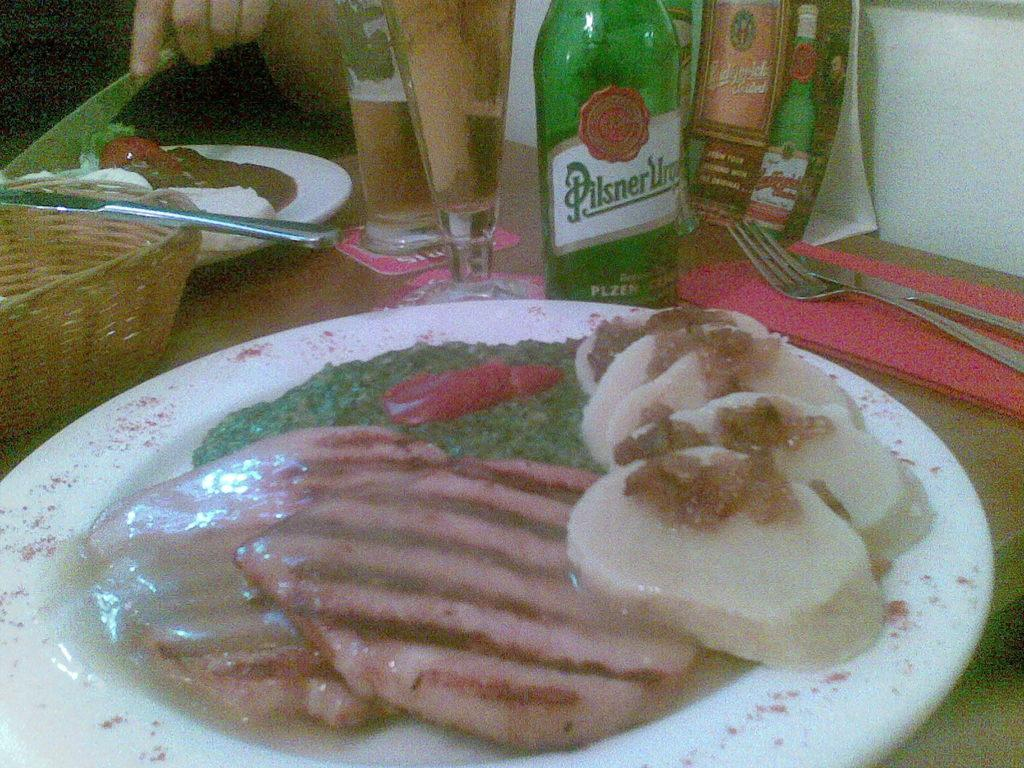What is the person in the image holding? The person in the image is holding a knife. What can be seen on the table in the image? There are serving plates with food, cutlery, glass tumblers, a woven basket, and beverage bottles on the table. What might be used for cutting or slicing in the image? The knife held by the person might be used for cutting or slicing. What might be used for drinking in the image? Glass tumblers are present in the image for drinking. Reasoning: Let' Let's think step by step in order to produce the conversation. We start by identifying the main subject in the image, which is the person holding a knife. Then, we expand the conversation to include other items that are also visible on the table, such as serving plates with food, cutlery, glass tumblers, a woven basket, and beverage bottles. Each question is designed to elicit a specific detail about the image that is known from the provided facts. Absurd Question/Answer: What type of eggnog can be seen in the woven basket in the image? There is no eggnog present in the image; the woven basket contains a different item. What type of drum is being played by the person in the image? There is no drum present in the image; the person is holding a knife. 